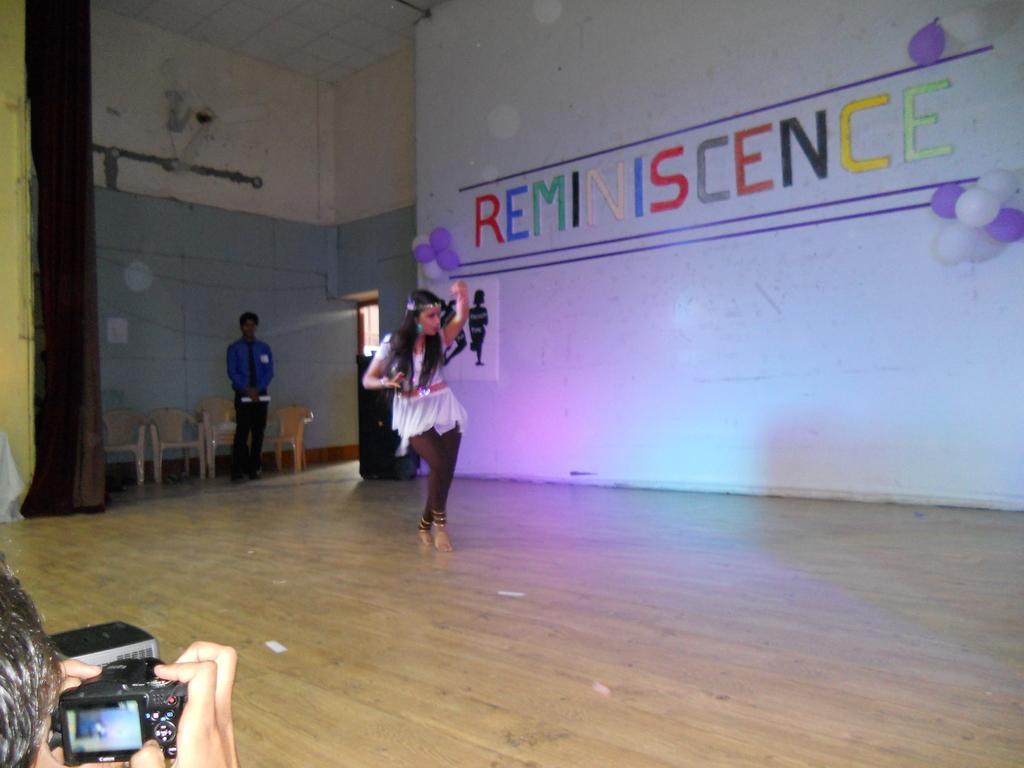Can you describe this image briefly? In this picture I can see a person dancing, there is a person standing, there is a person holding a camera, there are balloons on the wall, there are chairs and a fan. 